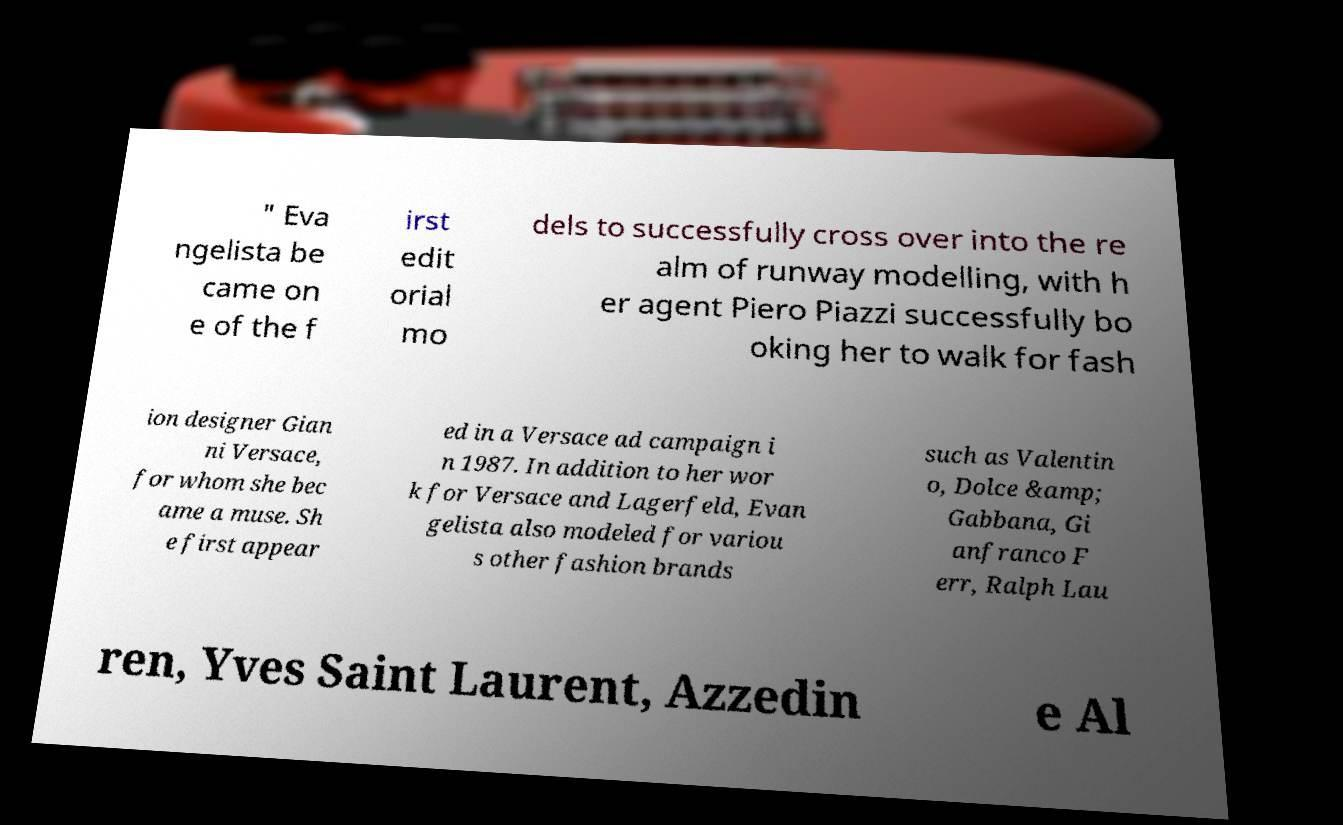Can you read and provide the text displayed in the image?This photo seems to have some interesting text. Can you extract and type it out for me? " Eva ngelista be came on e of the f irst edit orial mo dels to successfully cross over into the re alm of runway modelling, with h er agent Piero Piazzi successfully bo oking her to walk for fash ion designer Gian ni Versace, for whom she bec ame a muse. Sh e first appear ed in a Versace ad campaign i n 1987. In addition to her wor k for Versace and Lagerfeld, Evan gelista also modeled for variou s other fashion brands such as Valentin o, Dolce &amp; Gabbana, Gi anfranco F err, Ralph Lau ren, Yves Saint Laurent, Azzedin e Al 